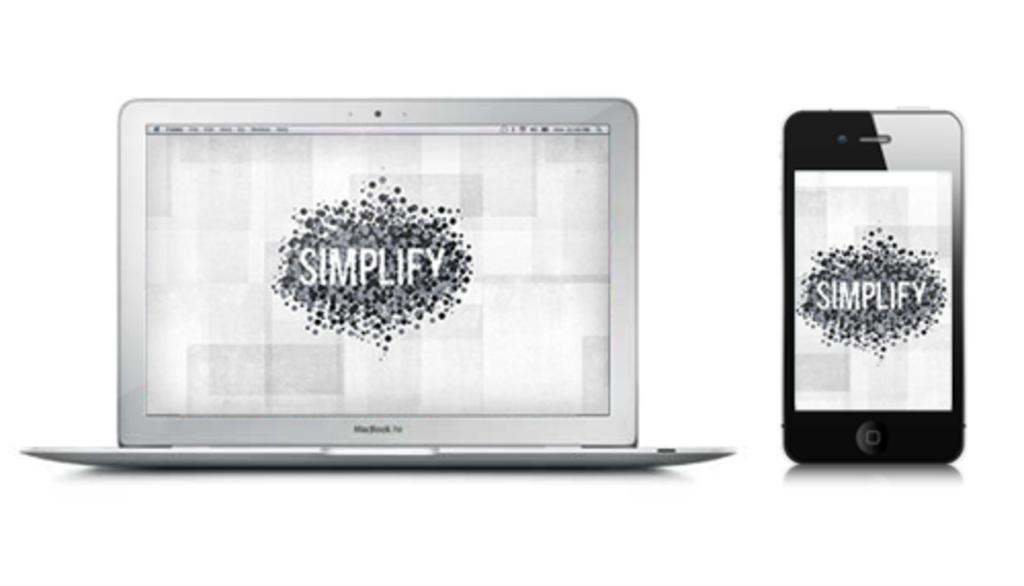What electronic device is visible in the image? There is a laptop in the image. What other electronic device can be seen in the image? There is a mobile in the image. What is the color scheme of the image? The image is in black and white. How many cakes are on the table in the image? There is no table or cakes present in the image; it features a laptop and a mobile in a black and white setting. What type of bird can be seen flying in the image? There are no birds, including crows, present in the image. 